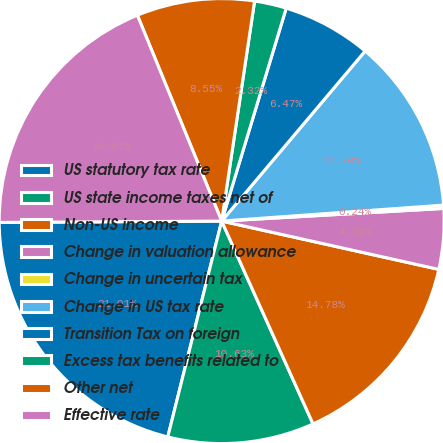Convert chart to OTSL. <chart><loc_0><loc_0><loc_500><loc_500><pie_chart><fcel>US statutory tax rate<fcel>US state income taxes net of<fcel>Non-US income<fcel>Change in valuation allowance<fcel>Change in uncertain tax<fcel>Change in US tax rate<fcel>Transition Tax on foreign<fcel>Excess tax benefits related to<fcel>Other net<fcel>Effective rate<nl><fcel>21.01%<fcel>10.63%<fcel>14.78%<fcel>4.39%<fcel>0.24%<fcel>12.7%<fcel>6.47%<fcel>2.32%<fcel>8.55%<fcel>18.91%<nl></chart> 